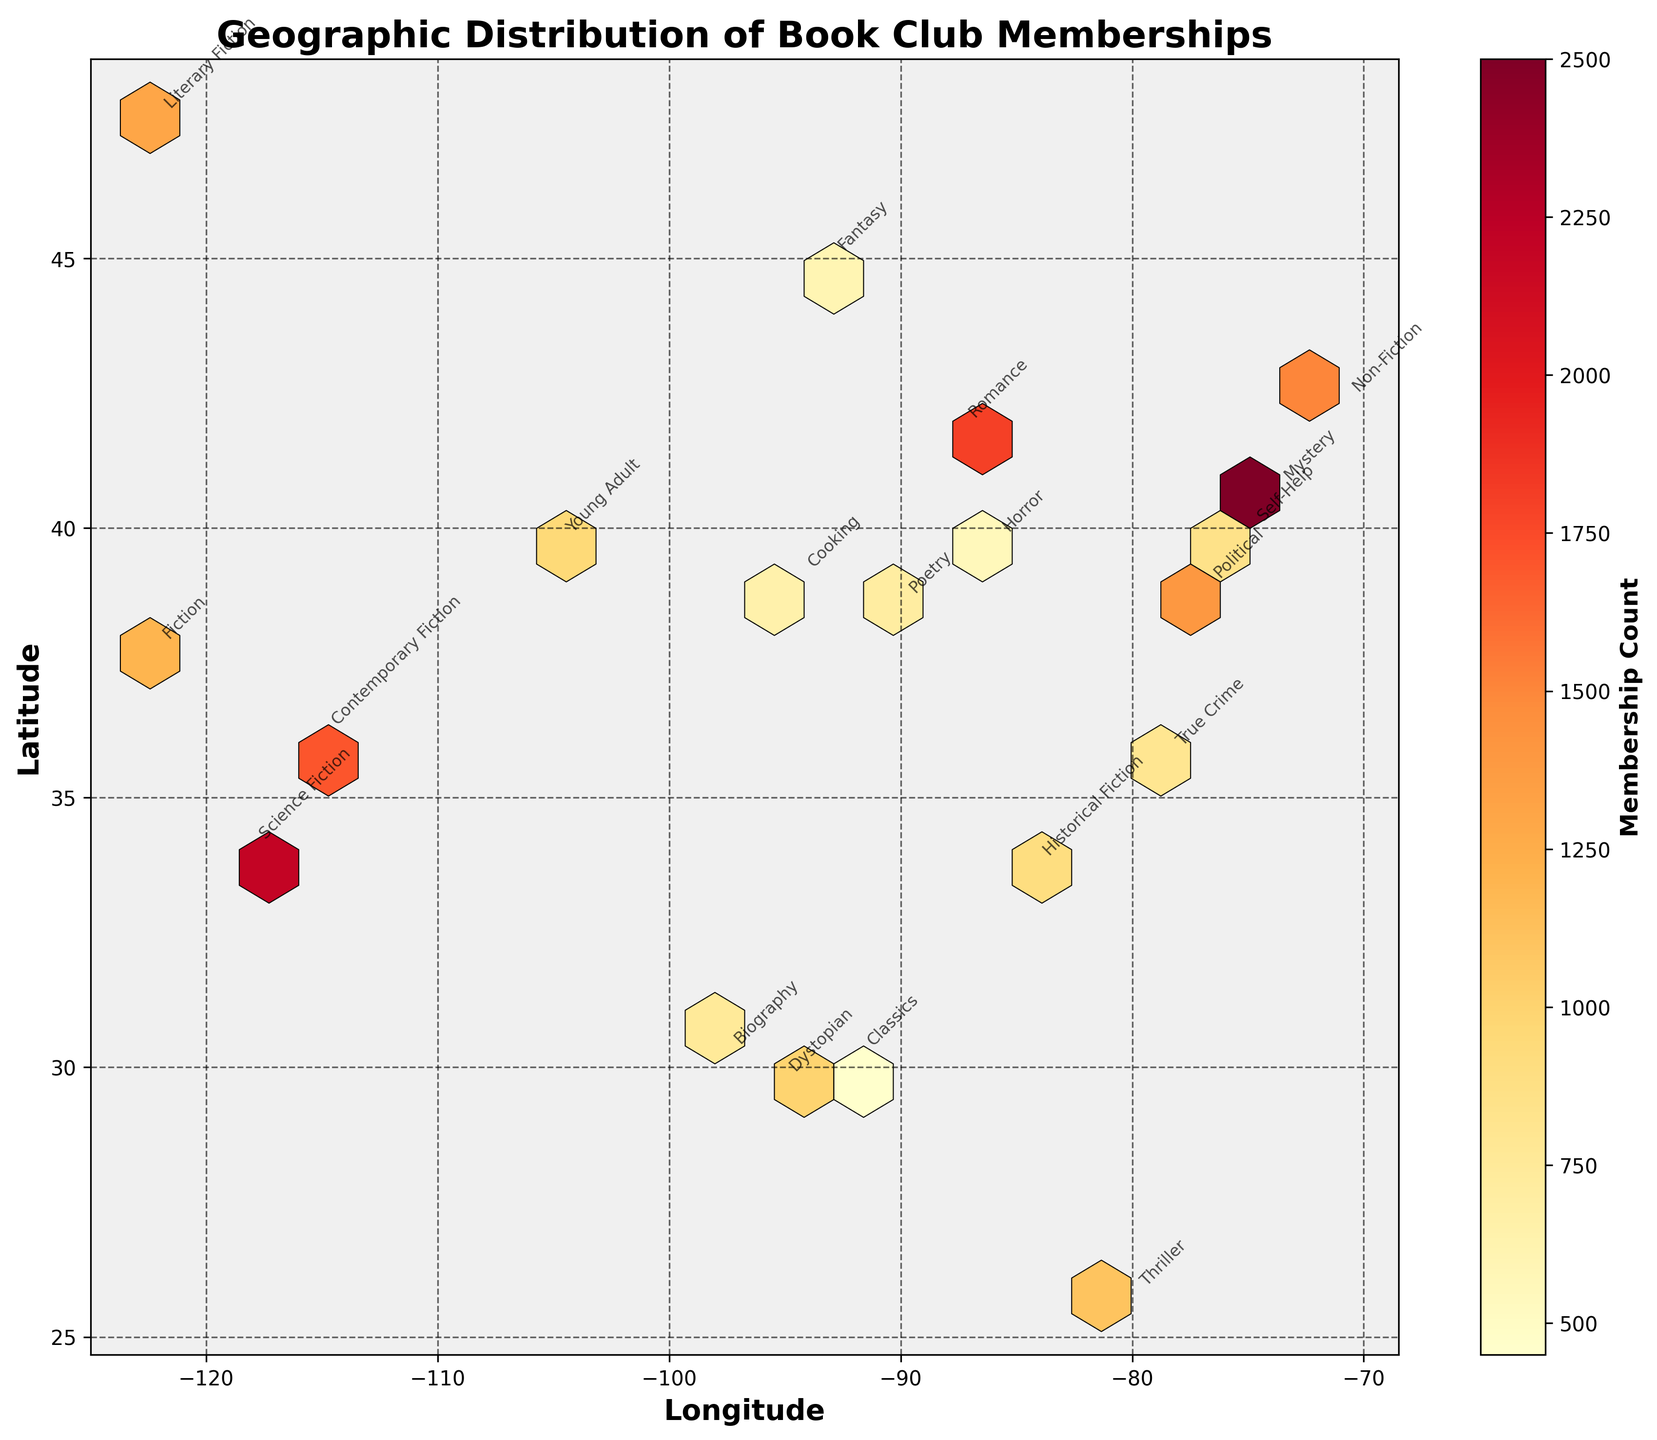What is the title of the Hexbin Plot? The title is typically displayed at the top of the plot. In this case, it reads "Geographic Distribution of Book Club Memberships".
Answer: Geographic Distribution of Book Club Memberships What does the color intensity on the plot represent? The color intensity in a Hexbin Plot often represents the density or count of data points in each hexagonal bin. Here, it shows the membership count.
Answer: Membership count How many book genres are annotated on the plot? Each unique value in the 'preferred_genre' column corresponds to an annotation. By counting the unique genres, we can determine the number.
Answer: 20 Which city has the highest book club membership count? The highest count is represented by the darkest hexbin. Looking for the annotation near this darkest bin, it points out to the city with the highest membership count.
Answer: New York City (40.7128, -74.0060) with a count of 2500 Which genre is most popular in San Francisco? Reading the annotation near the coordinates for San Francisco (-122.4194, 37.7749) provides the preferred genre for that city.
Answer: Fiction What is the average membership count across the plotted cities? Sum all the membership counts and divide by the number of cities. Adding 1200 + 2500 + 1800 + 2200 + 1500 + 900 + 750 + 1100 + 600 + 1300 + 850 + 700 + 950 + 550 + 1000 + 1400 + 650 + 800 + 1700 + 450 equals 26,900. Divide this sum by 20.
Answer: 1345 Which two cities have the closest geographic locations on the plot? By observing the coordinates (longitudes and latitudes) on the plot, look for the points closest to each other. San Francisco and Seattle (coordinates of -122.4194, 37.7749 and -122.3321, 47.6062, respectively) seem closest.
Answer: San Francisco and Seattle Is there a visible clustering of members in a specific region? Visually inspecting the plot shows if there are tight groupings of denser hexagonal bins. For example, higher densities around New York City and Los Angeles.
Answer: Yes, especially around New York City and Los Angeles Which genre has the smallest membership count, and in which city? By checking the annotations and corresponding counts, the smallest count is 450 for the genre 'Classics' in the city represented by the coordinates (30.2241, -92.0198).
Answer: Classics in a city at (30.2241, -92.0198) What is the range of book club memberships across all cities? The range is found by subtracting the smallest membership count from the largest. From 2500 (New York City) to 450 (a city at 30.2241, -92.0198), the range is 2500 - 450.
Answer: 2050 